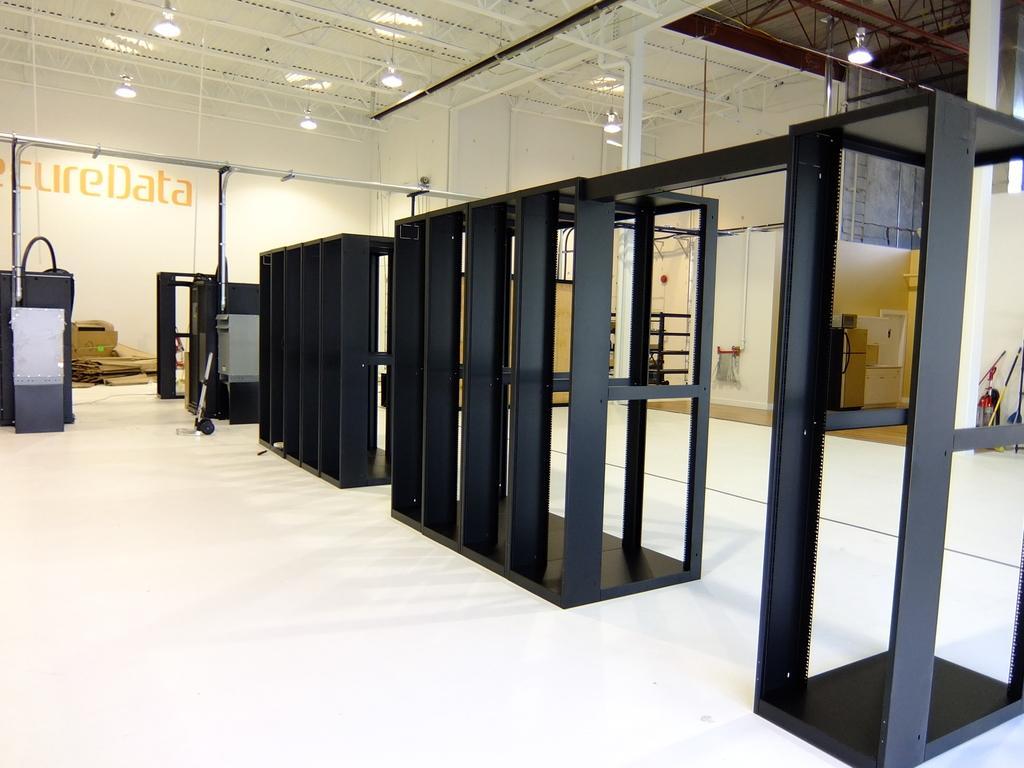In one or two sentences, can you explain what this image depicts? In this image, we can see an inside view of a warehouse. There are cabinets in the middle of the image. There are lights at the top of the image. There is an object on the left side of the image. 